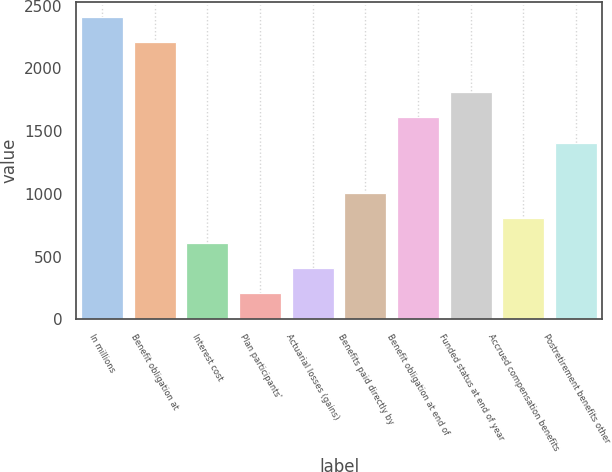Convert chart. <chart><loc_0><loc_0><loc_500><loc_500><bar_chart><fcel>In millions<fcel>Benefit obligation at<fcel>Interest cost<fcel>Plan participants'<fcel>Actuarial losses (gains)<fcel>Benefits paid directly by<fcel>Benefit obligation at end of<fcel>Funded status at end of year<fcel>Accrued compensation benefits<fcel>Postretirement benefits other<nl><fcel>2412<fcel>2211.5<fcel>607.5<fcel>206.5<fcel>407<fcel>1008.5<fcel>1610<fcel>1810.5<fcel>808<fcel>1409.5<nl></chart> 